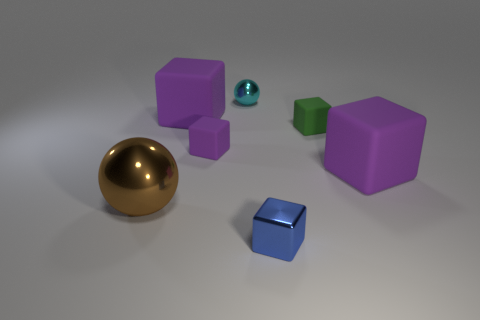Subtract all purple balls. How many purple cubes are left? 3 Subtract all tiny purple blocks. How many blocks are left? 4 Subtract all blue blocks. How many blocks are left? 4 Subtract all red blocks. Subtract all green spheres. How many blocks are left? 5 Add 1 small cyan spheres. How many objects exist? 8 Subtract all cubes. How many objects are left? 2 Add 7 small green metal cubes. How many small green metal cubes exist? 7 Subtract 0 gray cubes. How many objects are left? 7 Subtract all large brown rubber spheres. Subtract all big purple things. How many objects are left? 5 Add 4 brown balls. How many brown balls are left? 5 